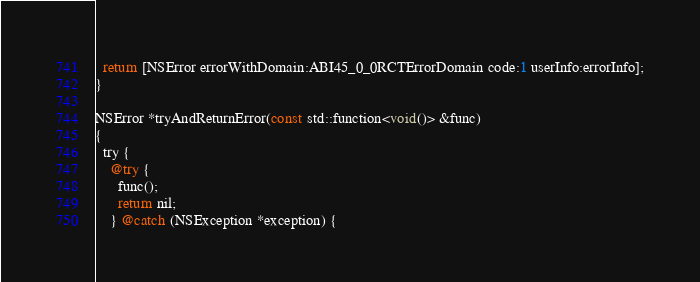Convert code to text. <code><loc_0><loc_0><loc_500><loc_500><_ObjectiveC_>  return [NSError errorWithDomain:ABI45_0_0RCTErrorDomain code:1 userInfo:errorInfo];
}

NSError *tryAndReturnError(const std::function<void()> &func)
{
  try {
    @try {
      func();
      return nil;
    } @catch (NSException *exception) {</code> 